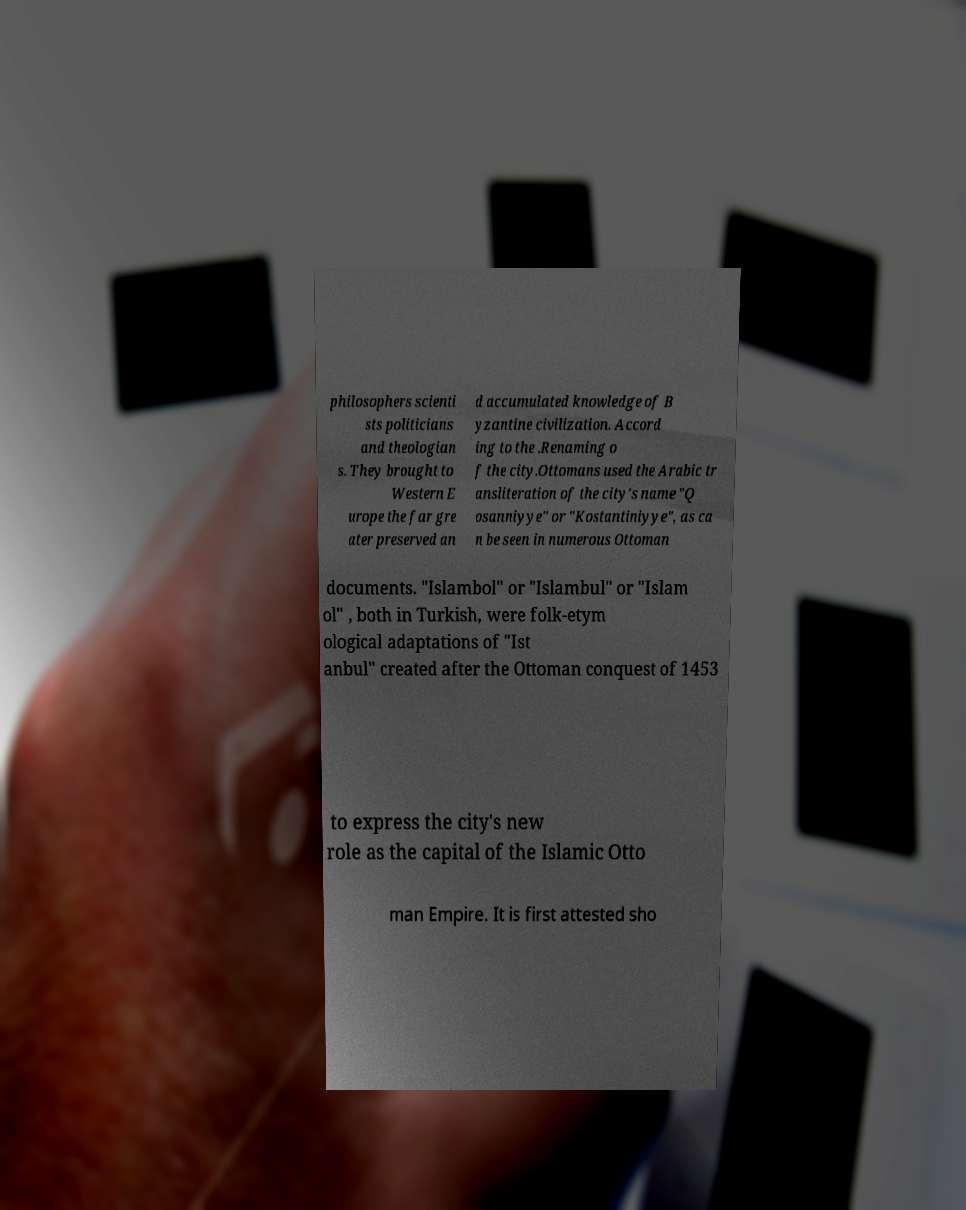Can you accurately transcribe the text from the provided image for me? philosophers scienti sts politicians and theologian s. They brought to Western E urope the far gre ater preserved an d accumulated knowledge of B yzantine civilization. Accord ing to the .Renaming o f the city.Ottomans used the Arabic tr ansliteration of the city's name "Q osanniyye" or "Kostantiniyye", as ca n be seen in numerous Ottoman documents. "Islambol" or "Islambul" or "Islam ol" , both in Turkish, were folk-etym ological adaptations of "Ist anbul" created after the Ottoman conquest of 1453 to express the city's new role as the capital of the Islamic Otto man Empire. It is first attested sho 